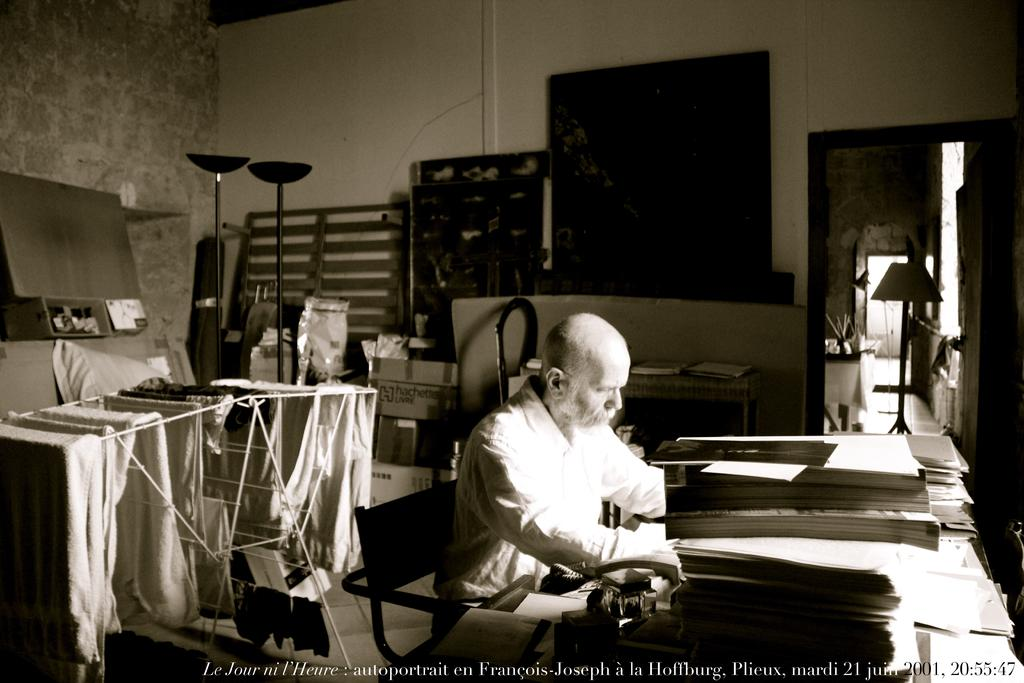What is the man in the image doing? The man is sitting at a table. What can be seen on the table in the image? Papers are present on the table. What object is visible in the image that is used for holding clothes? There is a clothes tray in the image. What is the purpose of the clothes tray in the image? Clothes are drying on the clothes tray. What type of band is performing on the roof in the image? There is no band or roof present in the image. 